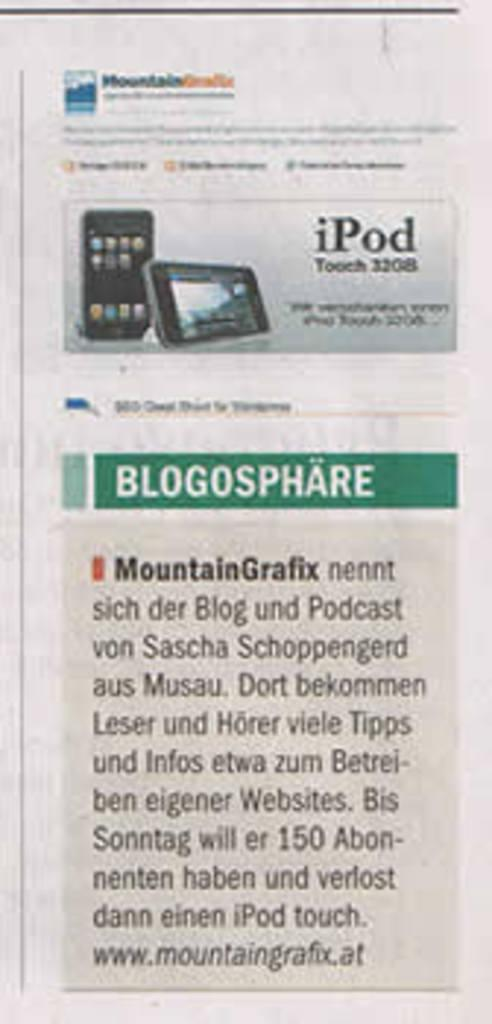Provide a one-sentence caption for the provided image. A newspaper article about blogs featuring MountainGrafix with a website listed at the bottom. 